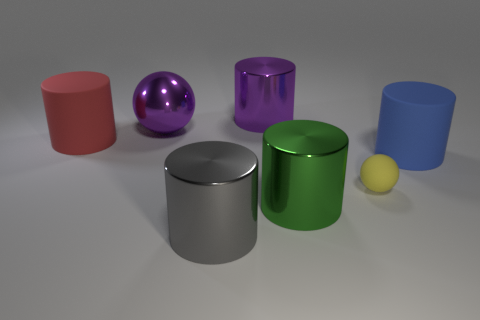Subtract all purple cylinders. How many cylinders are left? 4 Subtract all gray cylinders. How many cylinders are left? 4 Add 1 small cyan objects. How many objects exist? 8 Subtract all brown cylinders. Subtract all brown blocks. How many cylinders are left? 5 Subtract all spheres. How many objects are left? 5 Subtract 0 brown cylinders. How many objects are left? 7 Subtract all large purple balls. Subtract all big gray things. How many objects are left? 5 Add 6 tiny rubber spheres. How many tiny rubber spheres are left? 7 Add 3 large purple objects. How many large purple objects exist? 5 